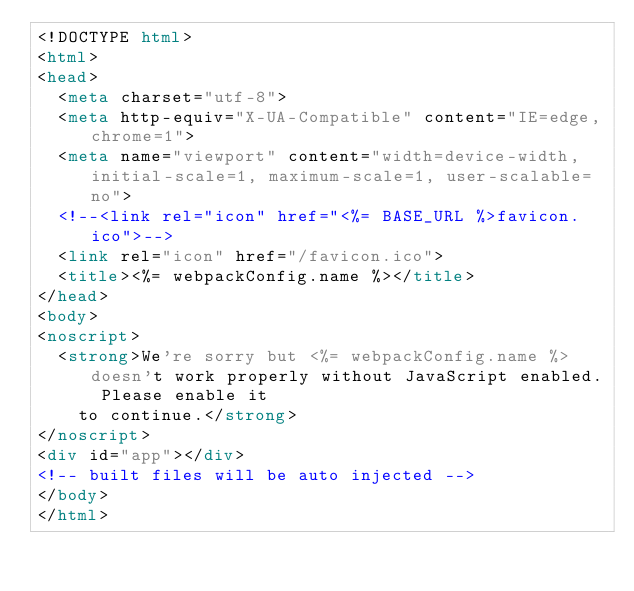Convert code to text. <code><loc_0><loc_0><loc_500><loc_500><_HTML_><!DOCTYPE html>
<html>
<head>
  <meta charset="utf-8">
  <meta http-equiv="X-UA-Compatible" content="IE=edge,chrome=1">
  <meta name="viewport" content="width=device-width, initial-scale=1, maximum-scale=1, user-scalable=no">
  <!--<link rel="icon" href="<%= BASE_URL %>favicon.ico">-->
  <link rel="icon" href="/favicon.ico">
  <title><%= webpackConfig.name %></title>
</head>
<body>
<noscript>
  <strong>We're sorry but <%= webpackConfig.name %> doesn't work properly without JavaScript enabled. Please enable it
    to continue.</strong>
</noscript>
<div id="app"></div>
<!-- built files will be auto injected -->
</body>
</html>
</code> 